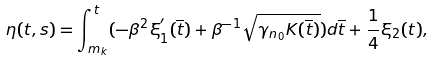Convert formula to latex. <formula><loc_0><loc_0><loc_500><loc_500>\eta ( t , s ) = \int _ { m _ { k } } ^ { t } ( - \beta ^ { 2 } \xi _ { 1 } ^ { ^ { \prime } } ( \overline { t } ) + \beta ^ { - 1 } \sqrt { \gamma _ { n _ { 0 } } K ( \overline { t } ) } ) d \overline { t } + \frac { 1 } { 4 } \xi _ { 2 } ( t ) ,</formula> 